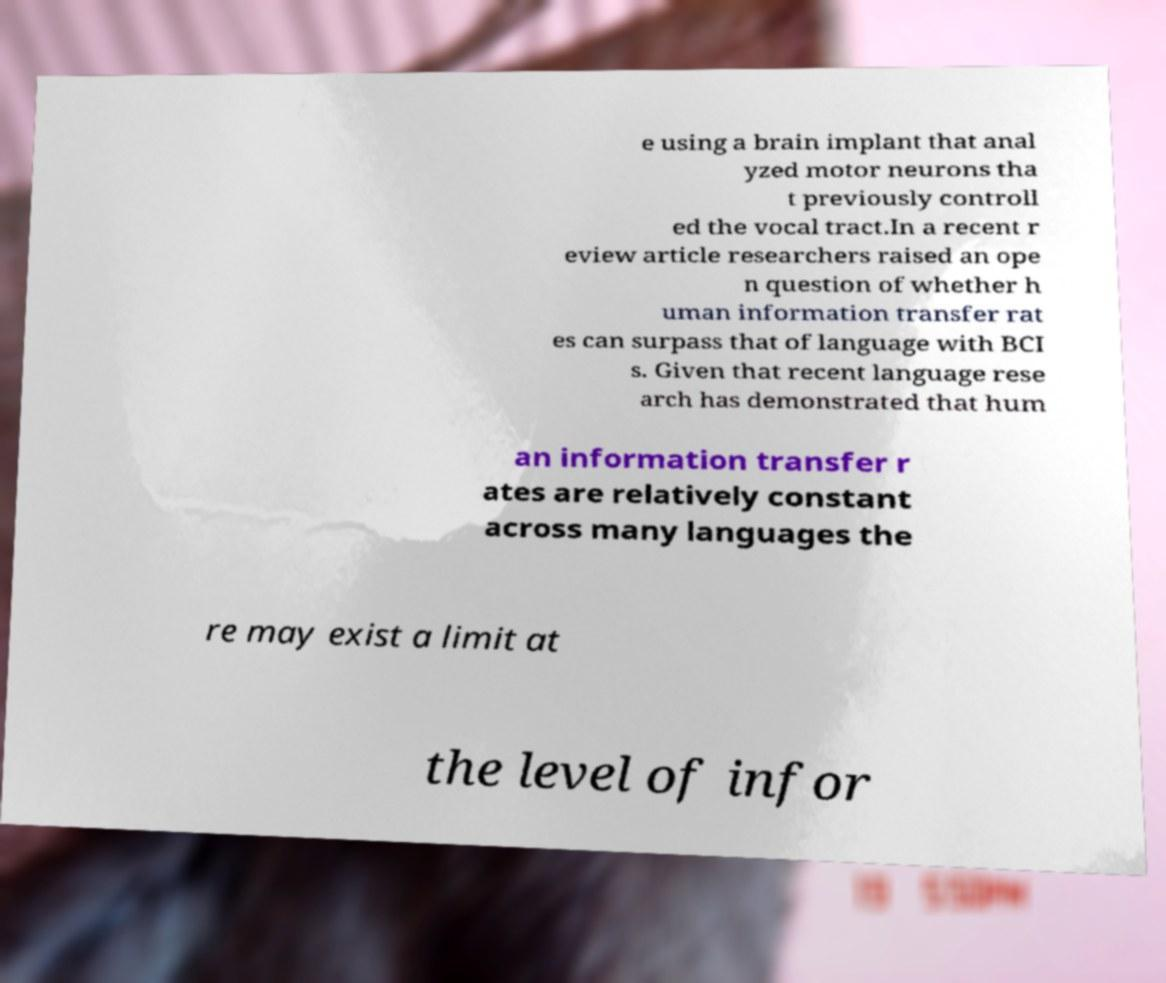For documentation purposes, I need the text within this image transcribed. Could you provide that? e using a brain implant that anal yzed motor neurons tha t previously controll ed the vocal tract.In a recent r eview article researchers raised an ope n question of whether h uman information transfer rat es can surpass that of language with BCI s. Given that recent language rese arch has demonstrated that hum an information transfer r ates are relatively constant across many languages the re may exist a limit at the level of infor 